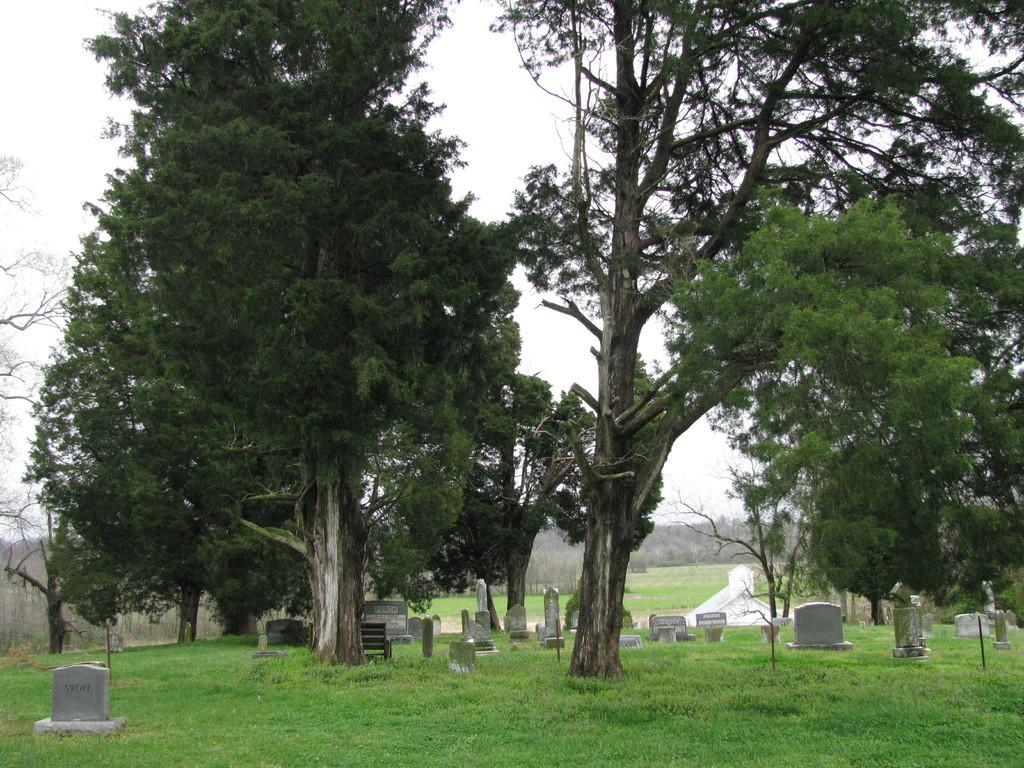What type of structures can be seen in the image? There are graveyard stones in the image. What natural elements are present in the image? There are trees in the middle of the image and grass on the ground. What can be seen in the background of the image? The sky is visible in the background of the image. What type of class is being held in the image? There is no class present in the image; it features a graveyard with stones, trees, grass, and a visible sky. 